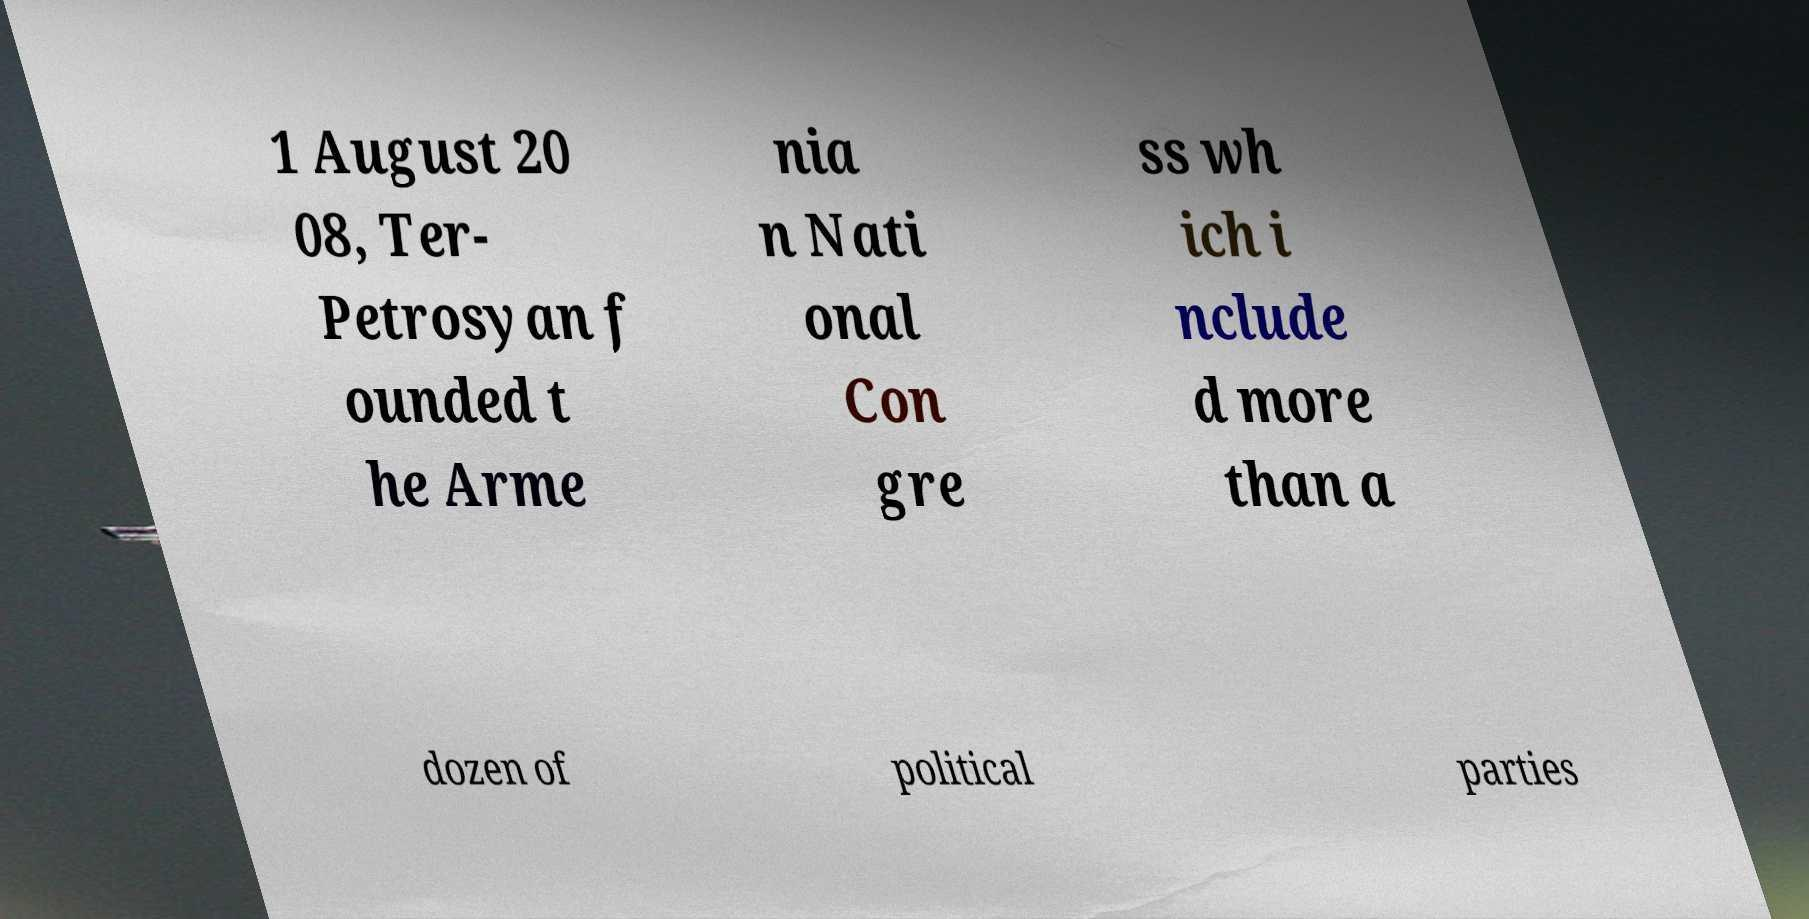Could you assist in decoding the text presented in this image and type it out clearly? 1 August 20 08, Ter- Petrosyan f ounded t he Arme nia n Nati onal Con gre ss wh ich i nclude d more than a dozen of political parties 